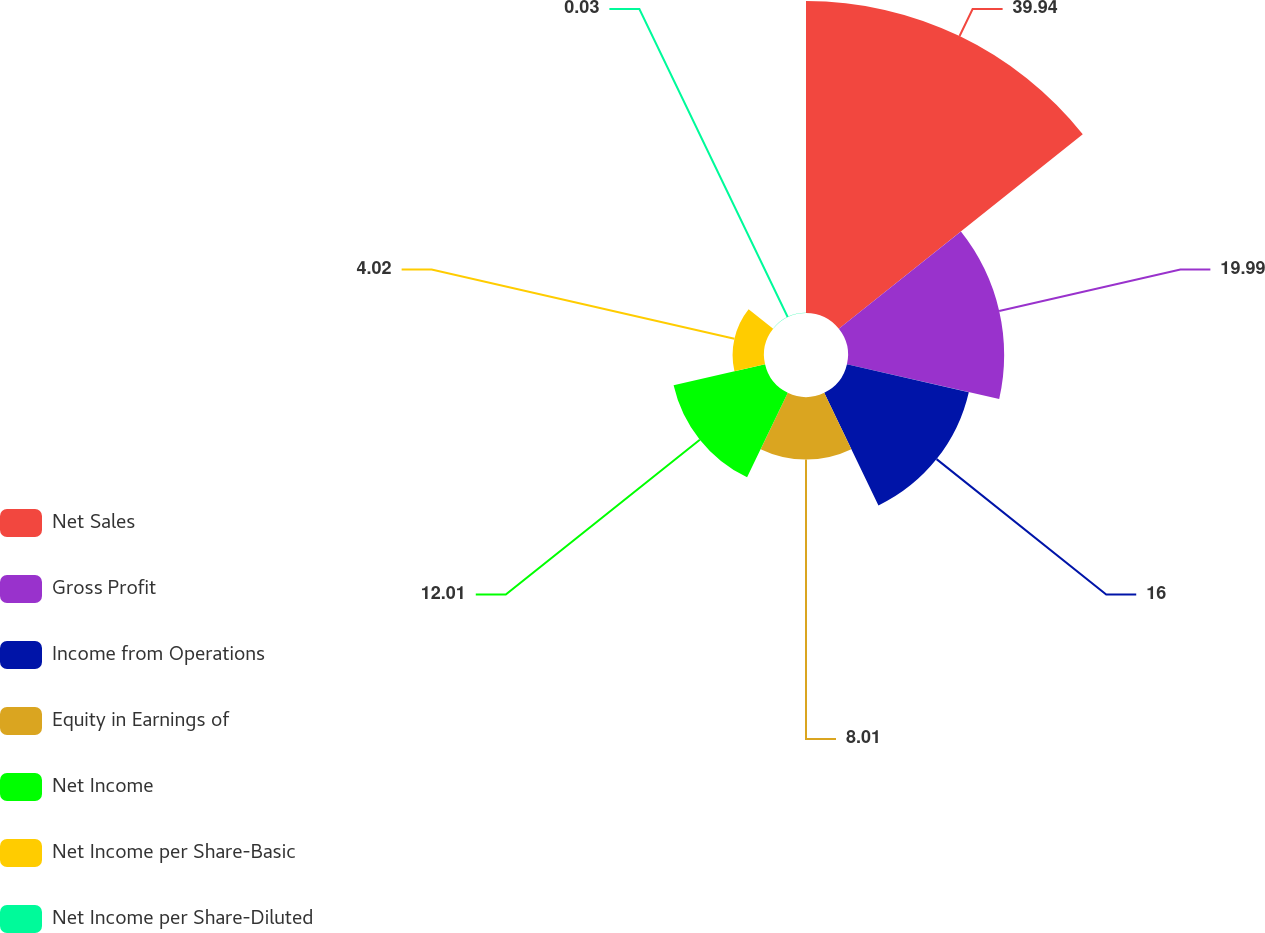Convert chart. <chart><loc_0><loc_0><loc_500><loc_500><pie_chart><fcel>Net Sales<fcel>Gross Profit<fcel>Income from Operations<fcel>Equity in Earnings of<fcel>Net Income<fcel>Net Income per Share-Basic<fcel>Net Income per Share-Diluted<nl><fcel>39.94%<fcel>19.99%<fcel>16.0%<fcel>8.01%<fcel>12.01%<fcel>4.02%<fcel>0.03%<nl></chart> 